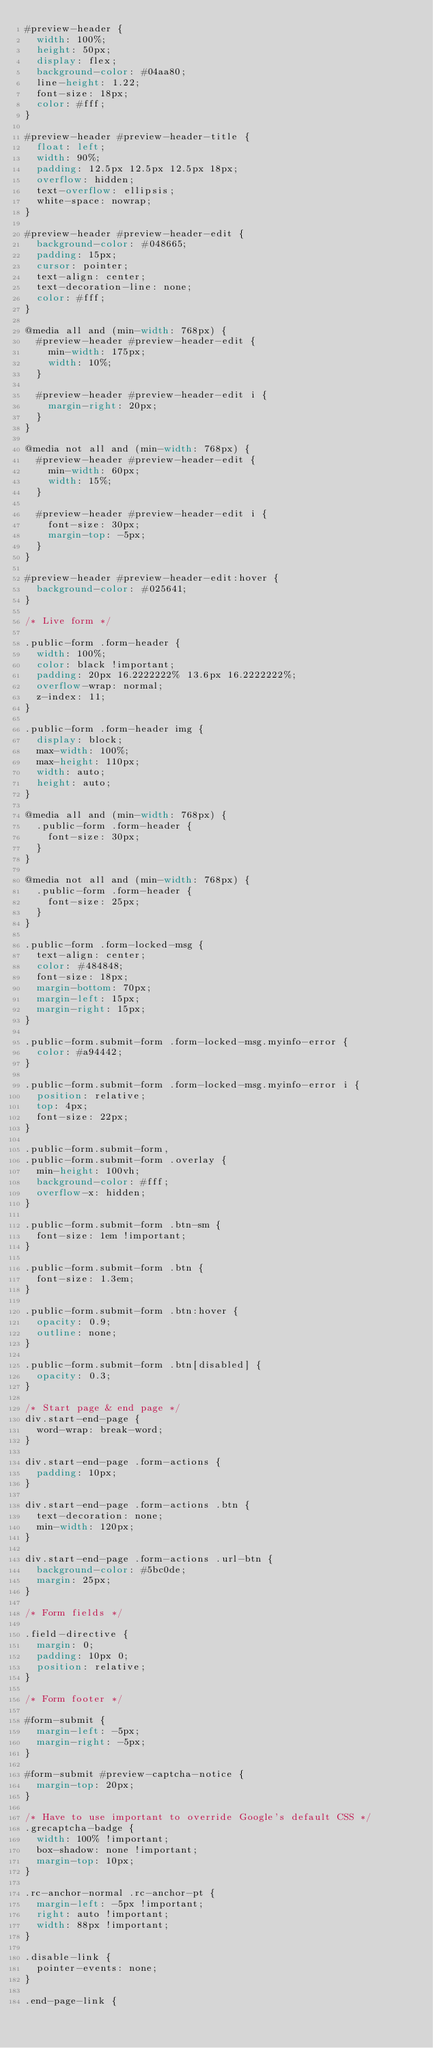Convert code to text. <code><loc_0><loc_0><loc_500><loc_500><_CSS_>#preview-header {
  width: 100%;
  height: 50px;
  display: flex;
  background-color: #04aa80;
  line-height: 1.22;
  font-size: 18px;
  color: #fff;
}

#preview-header #preview-header-title {
  float: left;
  width: 90%;
  padding: 12.5px 12.5px 12.5px 18px;
  overflow: hidden;
  text-overflow: ellipsis;
  white-space: nowrap;
}

#preview-header #preview-header-edit {
  background-color: #048665;
  padding: 15px;
  cursor: pointer;
  text-align: center;
  text-decoration-line: none;
  color: #fff;
}

@media all and (min-width: 768px) {
  #preview-header #preview-header-edit {
    min-width: 175px;
    width: 10%;
  }

  #preview-header #preview-header-edit i {
    margin-right: 20px;
  }
}

@media not all and (min-width: 768px) {
  #preview-header #preview-header-edit {
    min-width: 60px;
    width: 15%;
  }

  #preview-header #preview-header-edit i {
    font-size: 30px;
    margin-top: -5px;
  }
}

#preview-header #preview-header-edit:hover {
  background-color: #025641;
}

/* Live form */

.public-form .form-header {
  width: 100%;
  color: black !important;
  padding: 20px 16.2222222% 13.6px 16.2222222%;
  overflow-wrap: normal;
  z-index: 11;
}

.public-form .form-header img {
  display: block;
  max-width: 100%;
  max-height: 110px;
  width: auto;
  height: auto;
}

@media all and (min-width: 768px) {
  .public-form .form-header {
    font-size: 30px;
  }
}

@media not all and (min-width: 768px) {
  .public-form .form-header {
    font-size: 25px;
  }
}

.public-form .form-locked-msg {
  text-align: center;
  color: #484848;
  font-size: 18px;
  margin-bottom: 70px;
  margin-left: 15px;
  margin-right: 15px;
}

.public-form.submit-form .form-locked-msg.myinfo-error {
  color: #a94442;
}

.public-form.submit-form .form-locked-msg.myinfo-error i {
  position: relative;
  top: 4px;
  font-size: 22px;
}

.public-form.submit-form,
.public-form.submit-form .overlay {
  min-height: 100vh;
  background-color: #fff;
  overflow-x: hidden;
}

.public-form.submit-form .btn-sm {
  font-size: 1em !important;
}

.public-form.submit-form .btn {
  font-size: 1.3em;
}

.public-form.submit-form .btn:hover {
  opacity: 0.9;
  outline: none;
}

.public-form.submit-form .btn[disabled] {
  opacity: 0.3;
}

/* Start page & end page */
div.start-end-page {
  word-wrap: break-word;
}

div.start-end-page .form-actions {
  padding: 10px;
}

div.start-end-page .form-actions .btn {
  text-decoration: none;
  min-width: 120px;
}

div.start-end-page .form-actions .url-btn {
  background-color: #5bc0de;
  margin: 25px;
}

/* Form fields */

.field-directive {
  margin: 0;
  padding: 10px 0;
  position: relative;
}

/* Form footer */

#form-submit {
  margin-left: -5px;
  margin-right: -5px;
}

#form-submit #preview-captcha-notice {
  margin-top: 20px;
}

/* Have to use important to override Google's default CSS */
.grecaptcha-badge {
  width: 100% !important;
  box-shadow: none !important;
  margin-top: 10px;
}

.rc-anchor-normal .rc-anchor-pt {
  margin-left: -5px !important;
  right: auto !important;
  width: 88px !important;
}

.disable-link {
  pointer-events: none;
}

.end-page-link {</code> 